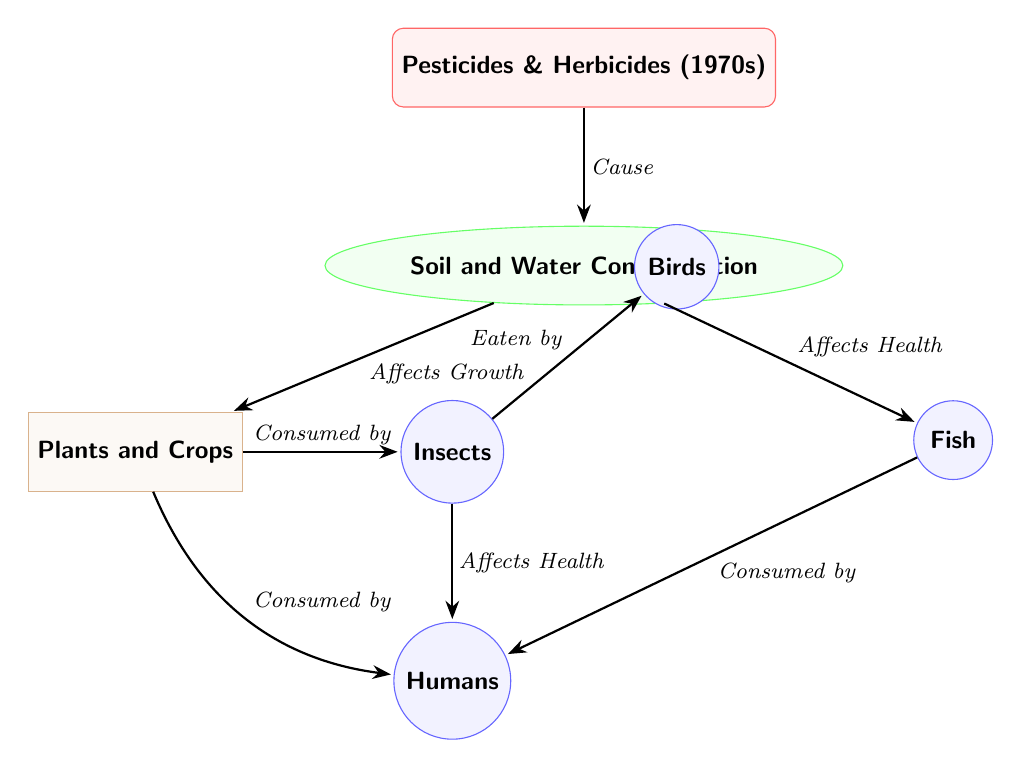What are the chemicals introduced in the 1970s? The diagram lists "Pesticides & Herbicides (1970s)" as the primary chemicals at the top.
Answer: Pesticides & Herbicides (1970s) What does the introduction of pesticides and herbicides cause in the environment? The diagram indicates that these chemicals lead to "Soil and Water Contamination."
Answer: Soil and Water Contamination How many types of fauna are affected by the pesticides and herbicides in the food chain? There are three fauna types labeled: Insects, Birds, and Fish. Thus, the number of fauna types is three.
Answer: 3 Which node is directly affected by "Soil and Water Contamination"? The diagram shows that "Plants and Crops" are directly below "Soil and Water Contamination," indicating they are affected by it.
Answer: Plants and Crops How do Insects relate to the Birds in the food chain? According to the diagram, Insects are "Consumed by" Birds, establishing a direct predator-prey relationship between the two nodes.
Answer: Consumed by What health effect do Fish have on Humans according to the diagram? The diagram shows that Fish are "Consumed by" Humans, highlighting the transfer of effects from water contaminant exposure.
Answer: Consumed by How do Plants and Crops affect Insects? The diagram states that Plants and Crops are "Consumed by" Insects, indicating that the health of Insects is dependent on the state of the Plants and Crops.
Answer: Consumed by If Soil and Water Contamination affects both Fish and Humans, what can be inferred about the food chain's impact on health? Since both Fish and Plants and Crops are linked to health impacts on Humans, the contamination has cascading effects that could undermine human health.
Answer: Cascading effects on health What is the relationship between Insects and Humans? The diagram indicates that Insects affect human health as they are both "Consumed by" Humans and also affect humans in other capacities, such as potential carriers of pesticide impacts.
Answer: Affects Health 